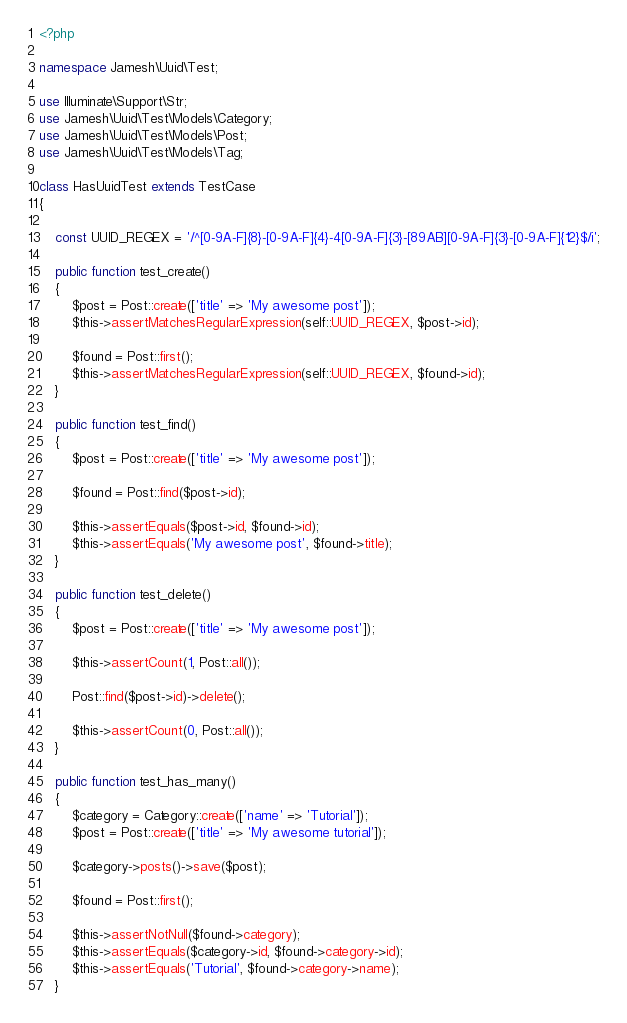Convert code to text. <code><loc_0><loc_0><loc_500><loc_500><_PHP_><?php

namespace Jamesh\Uuid\Test;

use Illuminate\Support\Str;
use Jamesh\Uuid\Test\Models\Category;
use Jamesh\Uuid\Test\Models\Post;
use Jamesh\Uuid\Test\Models\Tag;

class HasUuidTest extends TestCase
{

    const UUID_REGEX = '/^[0-9A-F]{8}-[0-9A-F]{4}-4[0-9A-F]{3}-[89AB][0-9A-F]{3}-[0-9A-F]{12}$/i';

    public function test_create()
    {
        $post = Post::create(['title' => 'My awesome post']);
        $this->assertMatchesRegularExpression(self::UUID_REGEX, $post->id);

        $found = Post::first();
        $this->assertMatchesRegularExpression(self::UUID_REGEX, $found->id);
    }

    public function test_find()
    {
        $post = Post::create(['title' => 'My awesome post']);

        $found = Post::find($post->id);

        $this->assertEquals($post->id, $found->id);
        $this->assertEquals('My awesome post', $found->title);
    }

    public function test_delete()
    {
        $post = Post::create(['title' => 'My awesome post']);

        $this->assertCount(1, Post::all());

        Post::find($post->id)->delete();

        $this->assertCount(0, Post::all());
    }

    public function test_has_many()
    {
        $category = Category::create(['name' => 'Tutorial']);
        $post = Post::create(['title' => 'My awesome tutorial']);

        $category->posts()->save($post);

        $found = Post::first();

        $this->assertNotNull($found->category);
        $this->assertEquals($category->id, $found->category->id);
        $this->assertEquals('Tutorial', $found->category->name);
    }
</code> 